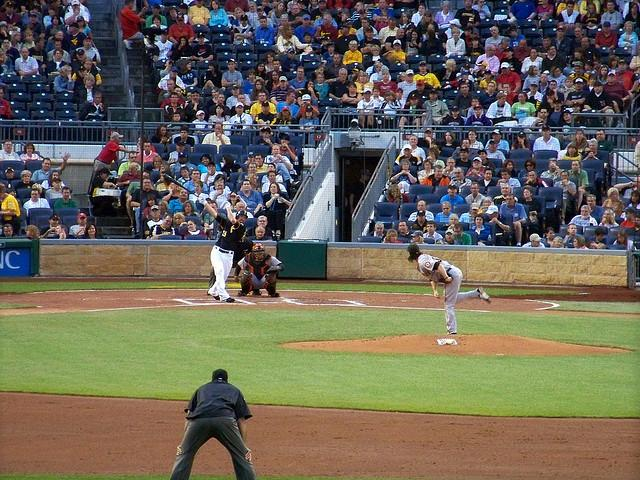What does the man in the center of the field want to achieve? out 